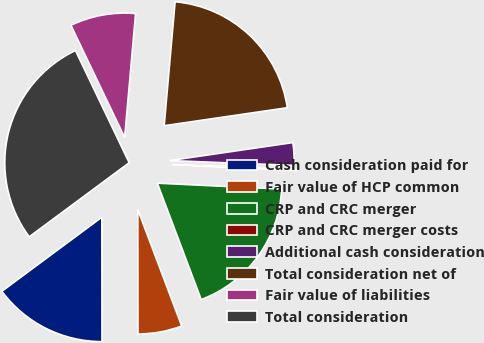Convert chart. <chart><loc_0><loc_0><loc_500><loc_500><pie_chart><fcel>Cash consideration paid for<fcel>Fair value of HCP common<fcel>CRP and CRC merger<fcel>CRP and CRC merger costs<fcel>Additional cash consideration<fcel>Total consideration net of<fcel>Fair value of liabilities<fcel>Total consideration<nl><fcel>14.87%<fcel>5.72%<fcel>18.5%<fcel>0.14%<fcel>2.93%<fcel>21.29%<fcel>8.51%<fcel>28.04%<nl></chart> 